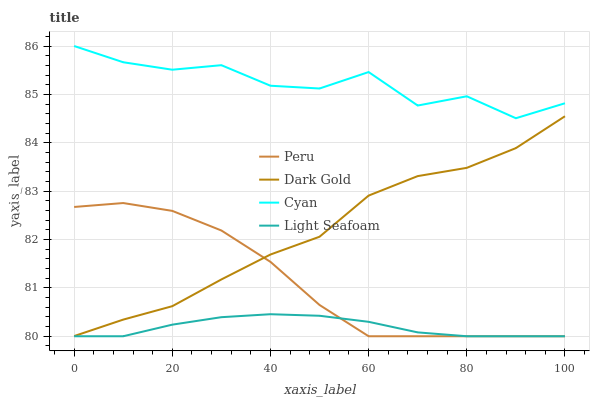Does Light Seafoam have the minimum area under the curve?
Answer yes or no. Yes. Does Cyan have the maximum area under the curve?
Answer yes or no. Yes. Does Peru have the minimum area under the curve?
Answer yes or no. No. Does Peru have the maximum area under the curve?
Answer yes or no. No. Is Light Seafoam the smoothest?
Answer yes or no. Yes. Is Cyan the roughest?
Answer yes or no. Yes. Is Peru the smoothest?
Answer yes or no. No. Is Peru the roughest?
Answer yes or no. No. Does Light Seafoam have the lowest value?
Answer yes or no. Yes. Does Dark Gold have the lowest value?
Answer yes or no. No. Does Cyan have the highest value?
Answer yes or no. Yes. Does Peru have the highest value?
Answer yes or no. No. Is Light Seafoam less than Cyan?
Answer yes or no. Yes. Is Cyan greater than Light Seafoam?
Answer yes or no. Yes. Does Light Seafoam intersect Peru?
Answer yes or no. Yes. Is Light Seafoam less than Peru?
Answer yes or no. No. Is Light Seafoam greater than Peru?
Answer yes or no. No. Does Light Seafoam intersect Cyan?
Answer yes or no. No. 